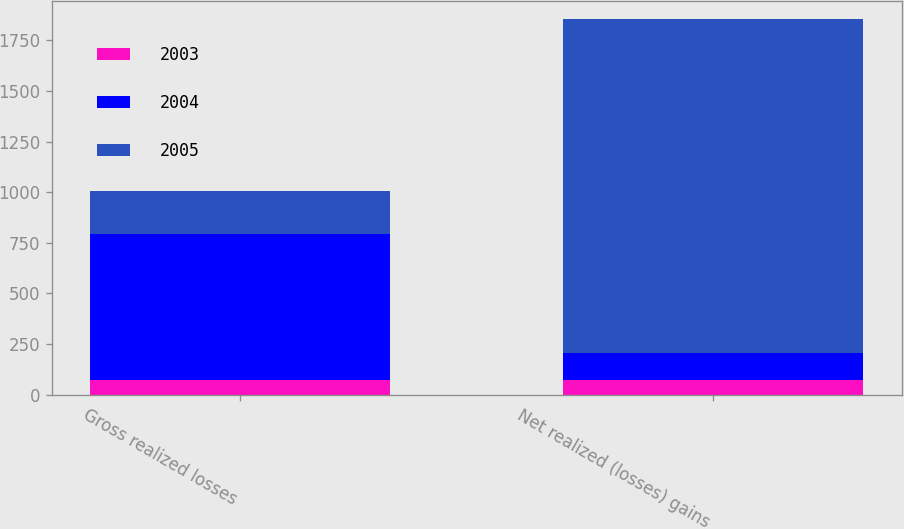Convert chart to OTSL. <chart><loc_0><loc_0><loc_500><loc_500><stacked_bar_chart><ecel><fcel>Gross realized losses<fcel>Net realized (losses) gains<nl><fcel>2003<fcel>70<fcel>70<nl><fcel>2004<fcel>723<fcel>138<nl><fcel>2005<fcel>213<fcel>1646<nl></chart> 